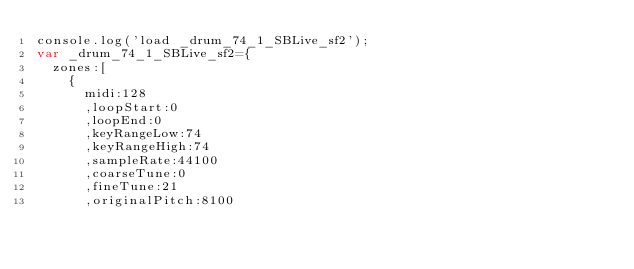<code> <loc_0><loc_0><loc_500><loc_500><_JavaScript_>console.log('load _drum_74_1_SBLive_sf2');
var _drum_74_1_SBLive_sf2={
	zones:[
		{
			midi:128
			,loopStart:0
			,loopEnd:0
			,keyRangeLow:74
			,keyRangeHigh:74
			,sampleRate:44100
			,coarseTune:0
			,fineTune:21
			,originalPitch:8100</code> 